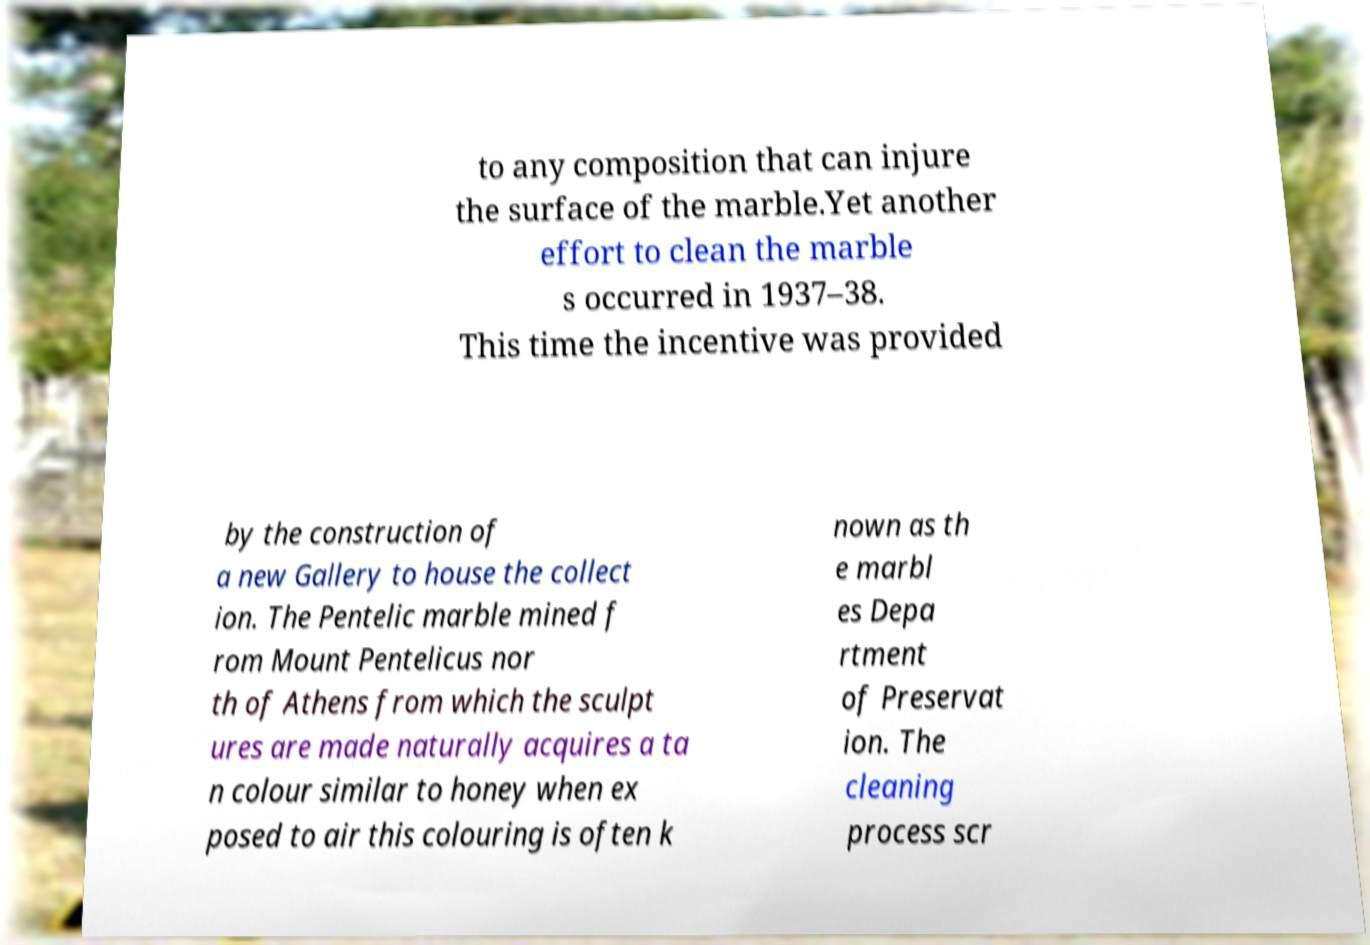What messages or text are displayed in this image? I need them in a readable, typed format. to any composition that can injure the surface of the marble.Yet another effort to clean the marble s occurred in 1937–38. This time the incentive was provided by the construction of a new Gallery to house the collect ion. The Pentelic marble mined f rom Mount Pentelicus nor th of Athens from which the sculpt ures are made naturally acquires a ta n colour similar to honey when ex posed to air this colouring is often k nown as th e marbl es Depa rtment of Preservat ion. The cleaning process scr 